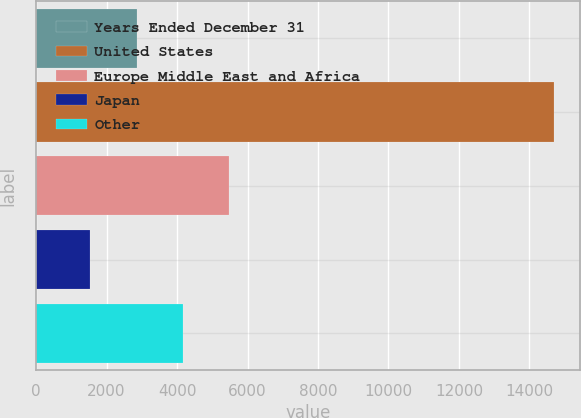<chart> <loc_0><loc_0><loc_500><loc_500><bar_chart><fcel>Years Ended December 31<fcel>United States<fcel>Europe Middle East and Africa<fcel>Japan<fcel>Other<nl><fcel>2848.97<fcel>14690.9<fcel>5480.51<fcel>1533.2<fcel>4164.74<nl></chart> 